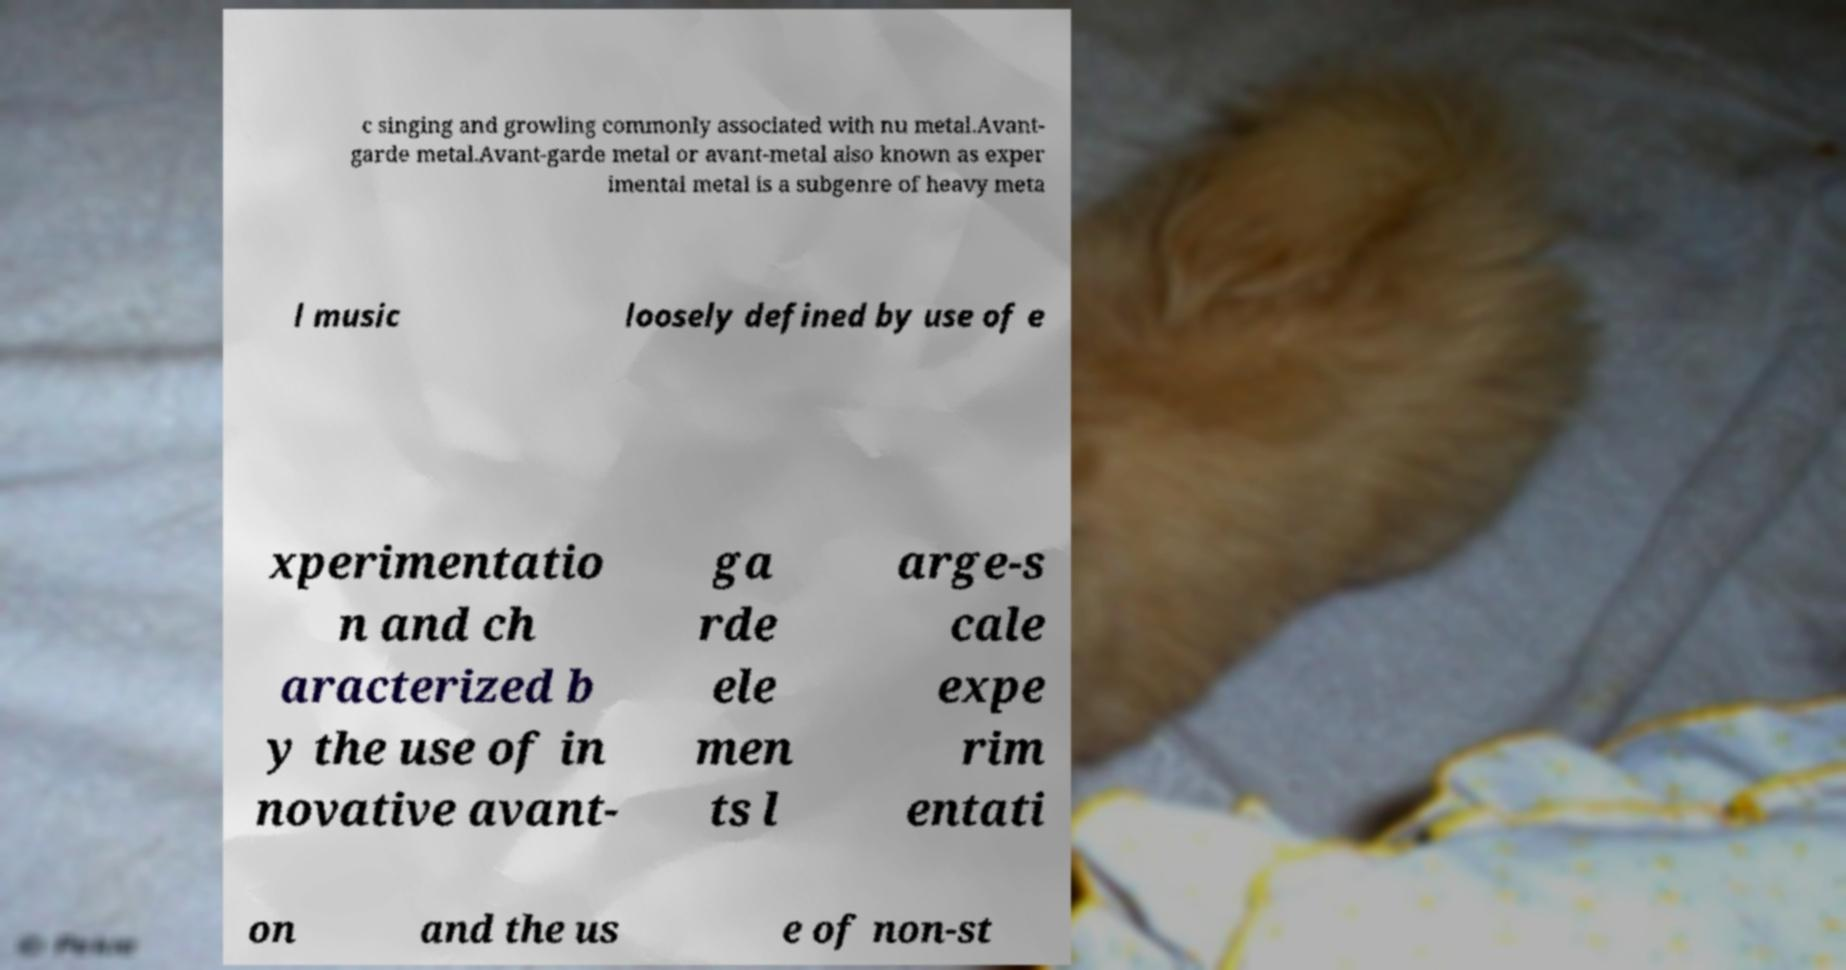Can you accurately transcribe the text from the provided image for me? c singing and growling commonly associated with nu metal.Avant- garde metal.Avant-garde metal or avant-metal also known as exper imental metal is a subgenre of heavy meta l music loosely defined by use of e xperimentatio n and ch aracterized b y the use of in novative avant- ga rde ele men ts l arge-s cale expe rim entati on and the us e of non-st 